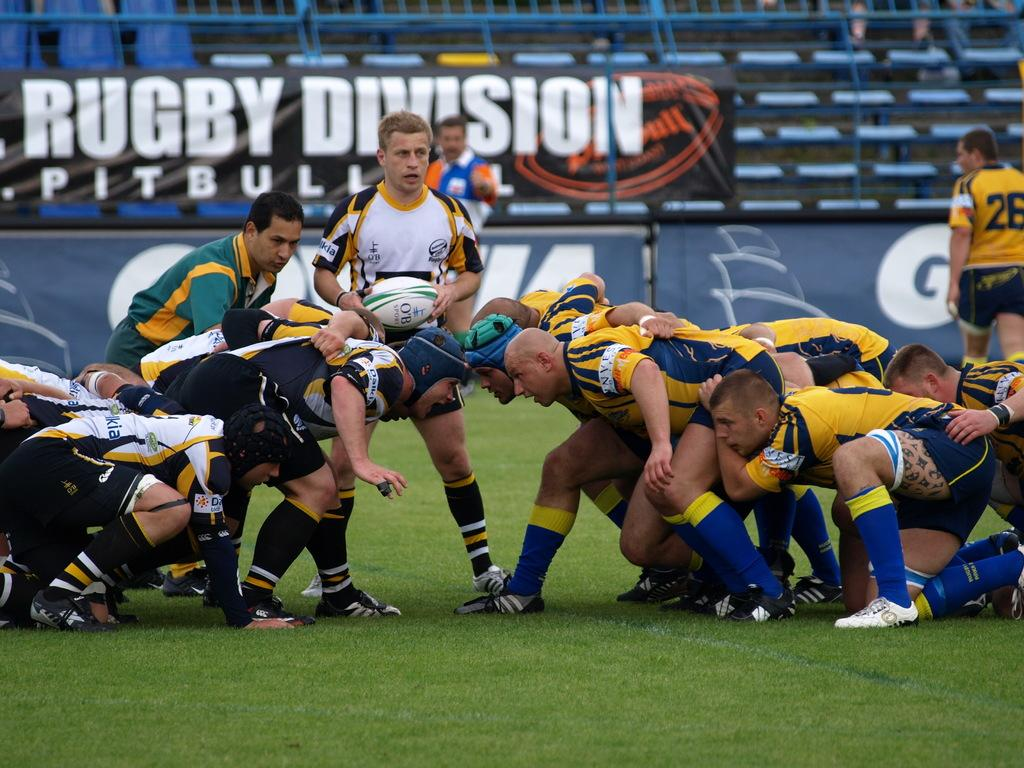<image>
Provide a brief description of the given image. A rugby game takes place in front of a banner that says Rugby Division Pitbull. 